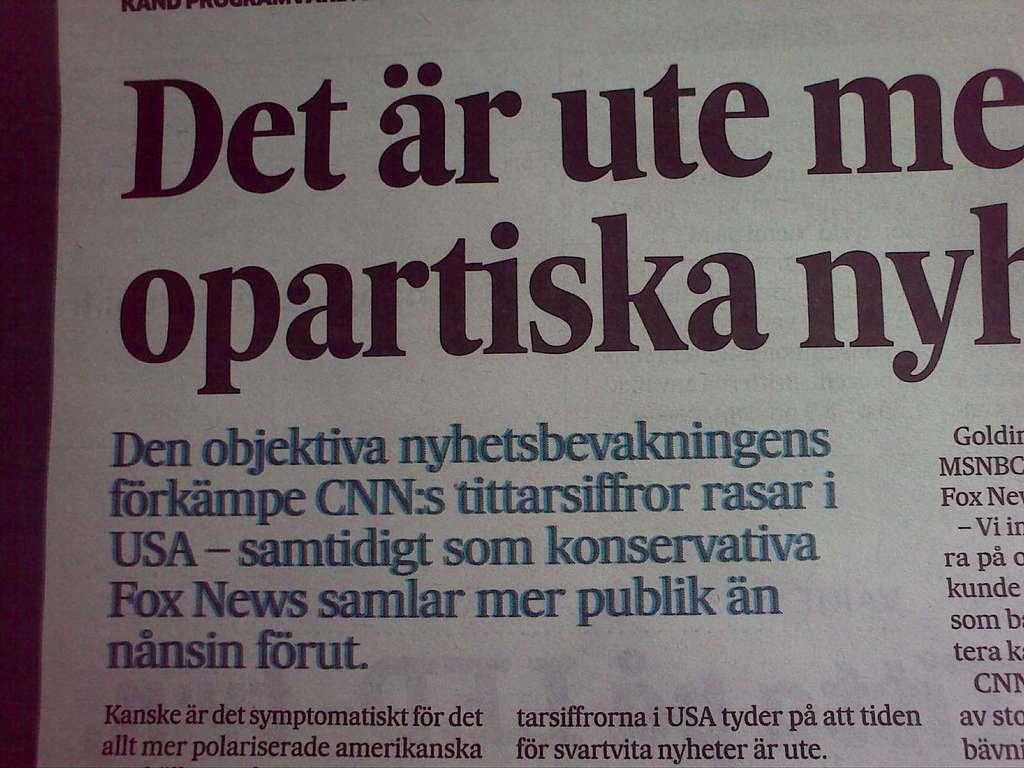<image>
Present a compact description of the photo's key features. Newsprint in a language other than English includes something about CNN. 